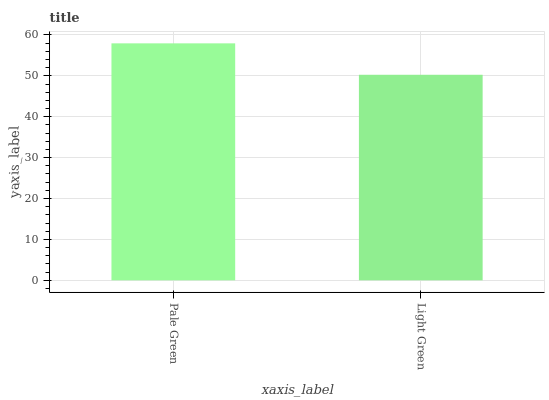Is Light Green the maximum?
Answer yes or no. No. Is Pale Green greater than Light Green?
Answer yes or no. Yes. Is Light Green less than Pale Green?
Answer yes or no. Yes. Is Light Green greater than Pale Green?
Answer yes or no. No. Is Pale Green less than Light Green?
Answer yes or no. No. Is Pale Green the high median?
Answer yes or no. Yes. Is Light Green the low median?
Answer yes or no. Yes. Is Light Green the high median?
Answer yes or no. No. Is Pale Green the low median?
Answer yes or no. No. 